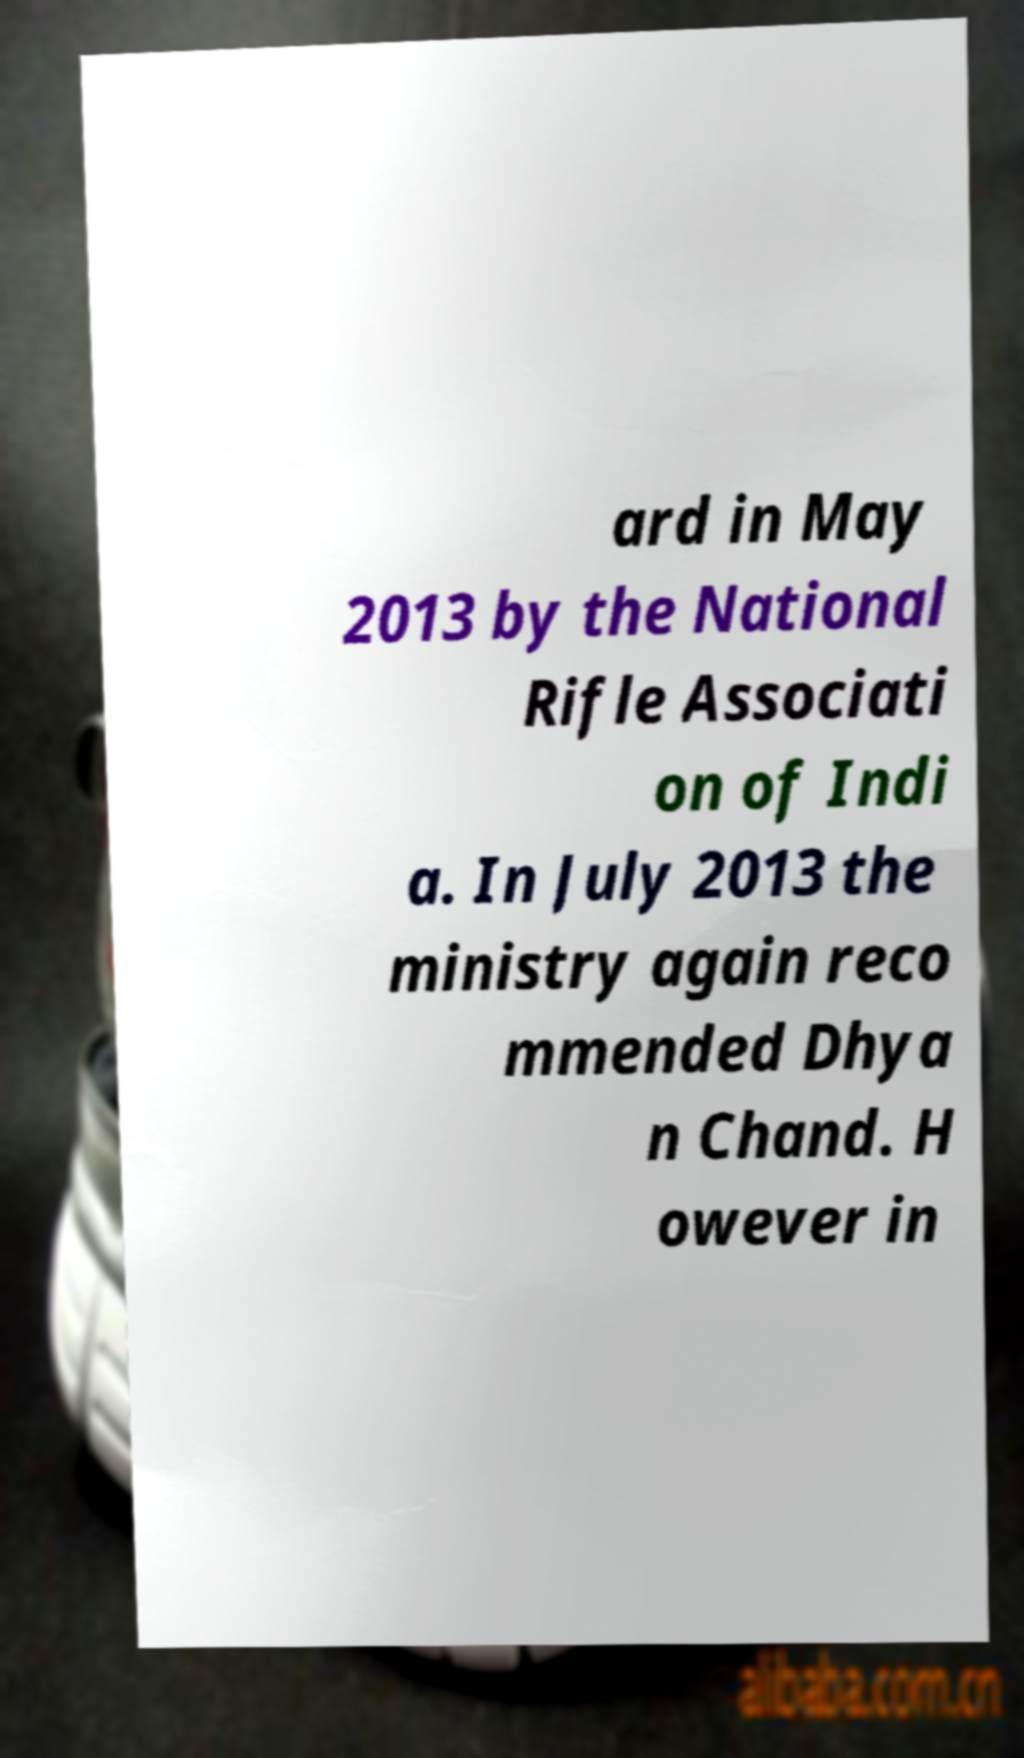Please read and relay the text visible in this image. What does it say? ard in May 2013 by the National Rifle Associati on of Indi a. In July 2013 the ministry again reco mmended Dhya n Chand. H owever in 